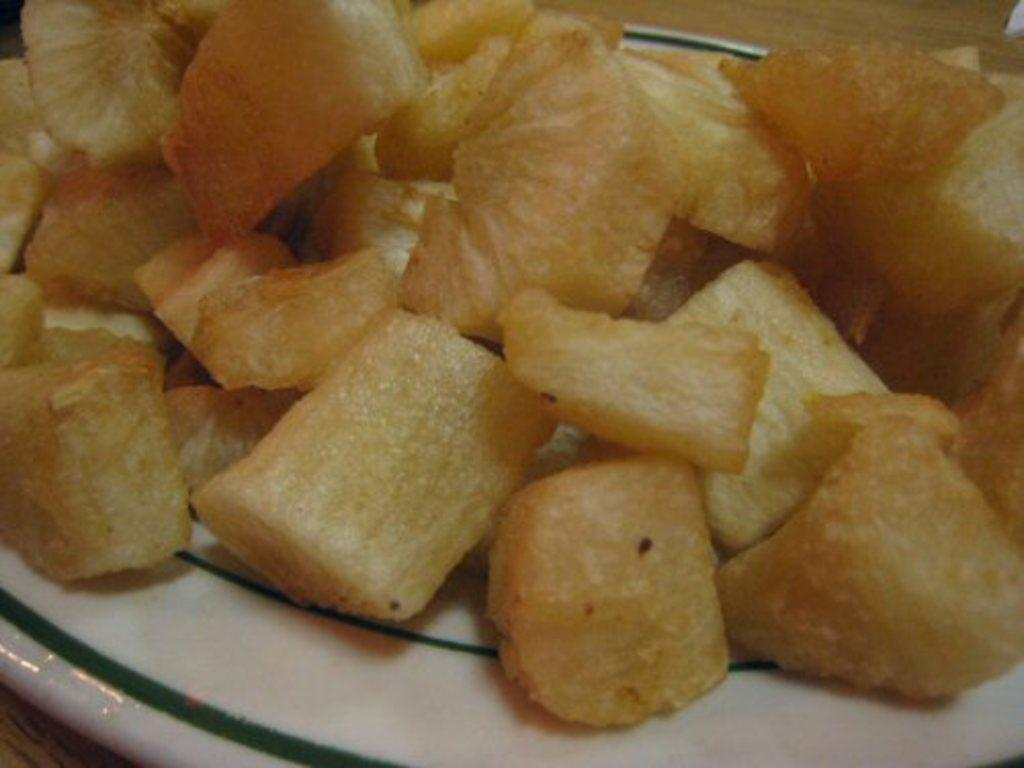What is present on the plate in the image? There is food on the plate in the image. Can you describe the plate itself? The facts provided do not give any specific details about the plate, so we cannot describe it further. What type of jewel is placed on the border of the plate in the image? There is no mention of a border or a jewel in the image, so we cannot answer this question. 